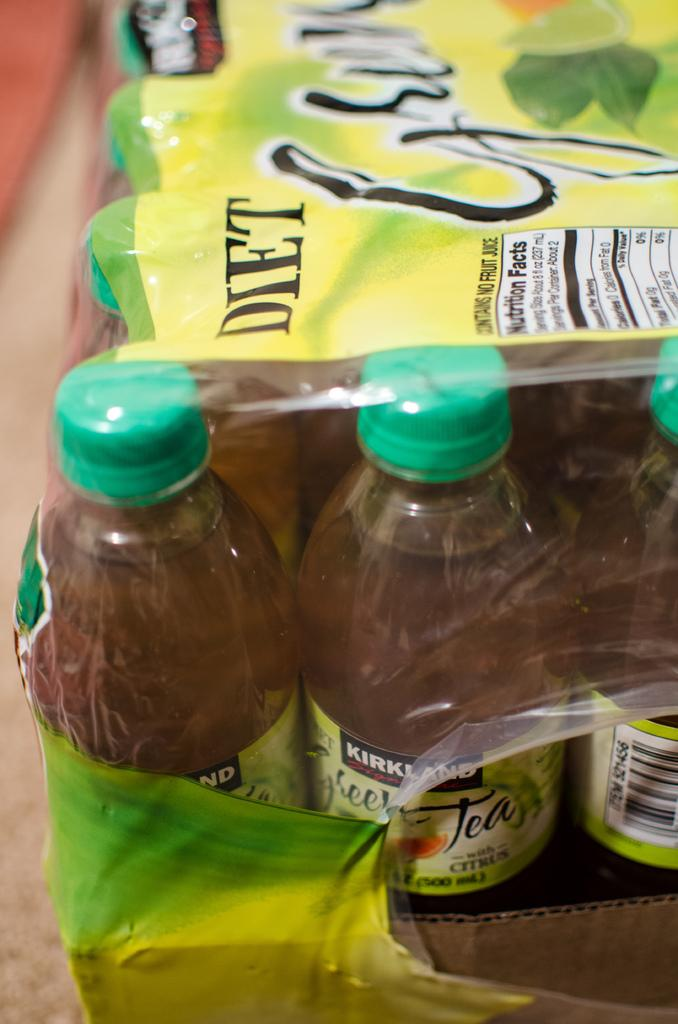<image>
Give a short and clear explanation of the subsequent image. shrink wrapped bottles of kirkland diet green tea 